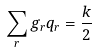Convert formula to latex. <formula><loc_0><loc_0><loc_500><loc_500>\sum _ { r } g _ { r } q _ { r } = \frac { k } { 2 }</formula> 